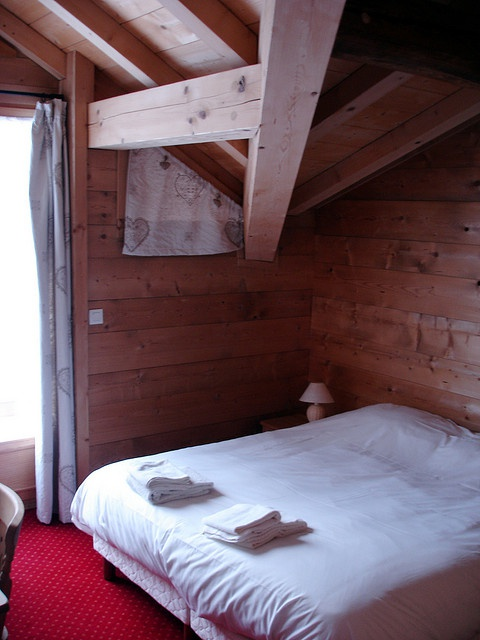Describe the objects in this image and their specific colors. I can see bed in maroon, gray, darkgray, and lavender tones and chair in maroon, black, darkgray, and lavender tones in this image. 